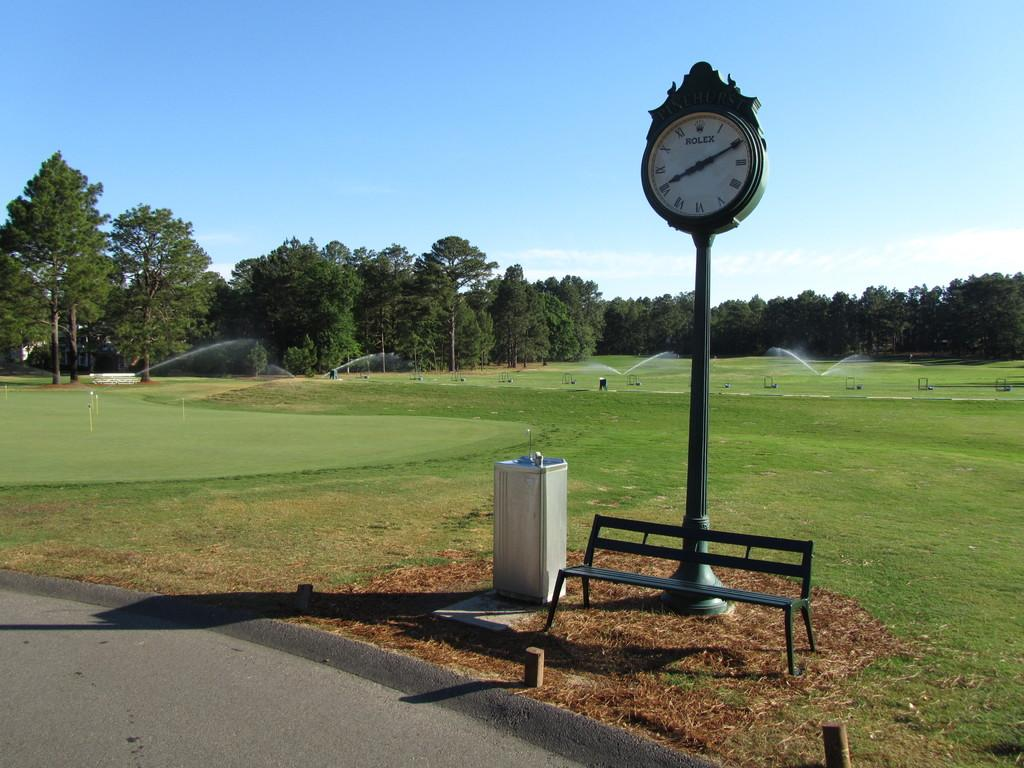<image>
Give a short and clear explanation of the subsequent image. a clock outside that reads the time 2:40 